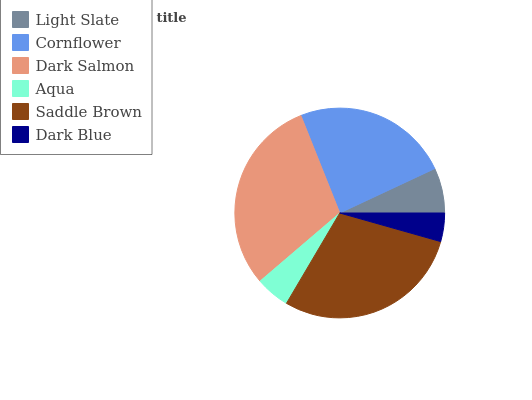Is Dark Blue the minimum?
Answer yes or no. Yes. Is Dark Salmon the maximum?
Answer yes or no. Yes. Is Cornflower the minimum?
Answer yes or no. No. Is Cornflower the maximum?
Answer yes or no. No. Is Cornflower greater than Light Slate?
Answer yes or no. Yes. Is Light Slate less than Cornflower?
Answer yes or no. Yes. Is Light Slate greater than Cornflower?
Answer yes or no. No. Is Cornflower less than Light Slate?
Answer yes or no. No. Is Cornflower the high median?
Answer yes or no. Yes. Is Light Slate the low median?
Answer yes or no. Yes. Is Dark Blue the high median?
Answer yes or no. No. Is Saddle Brown the low median?
Answer yes or no. No. 